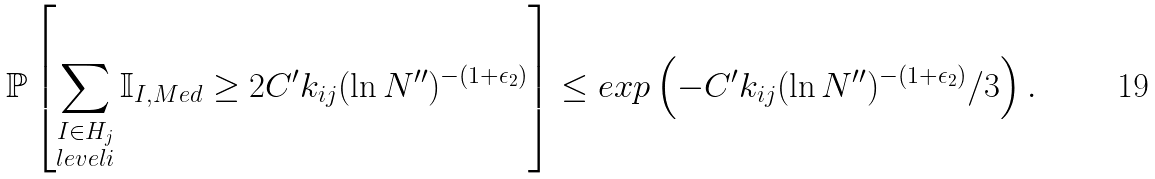Convert formula to latex. <formula><loc_0><loc_0><loc_500><loc_500>\mathbb { P } \left [ \sum _ { \substack { I \in H _ { j } \\ l e v e l i } } \mathbb { I } _ { I , M e d } \geq 2 C ^ { \prime } k _ { i j } ( \ln N ^ { \prime \prime } ) ^ { - ( 1 + \epsilon _ { 2 } ) } \right ] \leq e x p \left ( - C ^ { \prime } k _ { i j } ( \ln N ^ { \prime \prime } ) ^ { - ( 1 + \epsilon _ { 2 } ) } / 3 \right ) .</formula> 